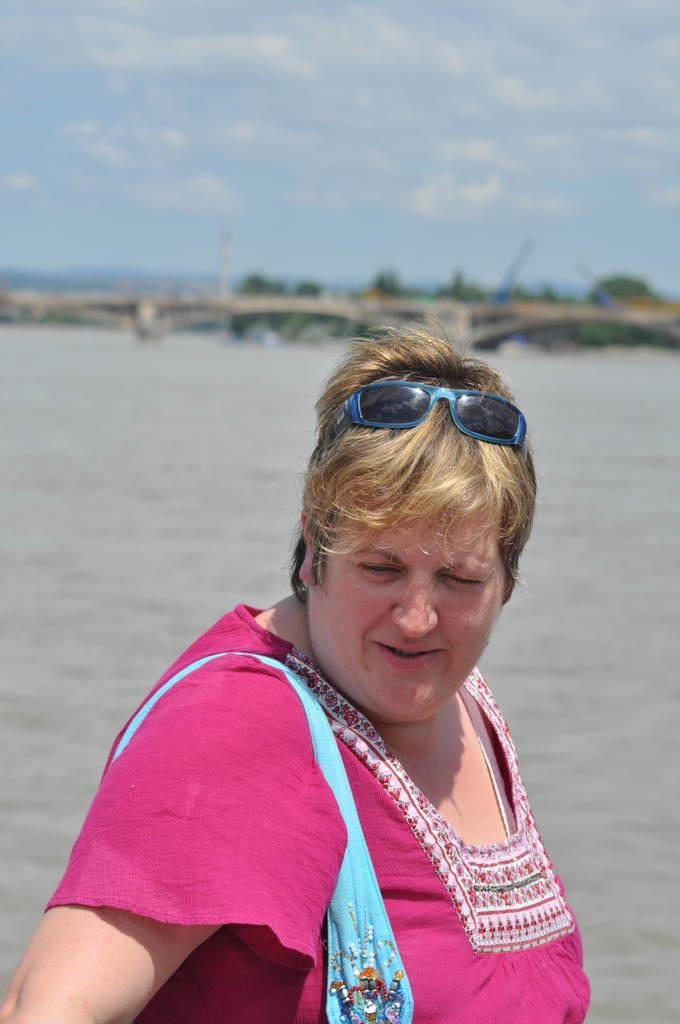What can be seen on the person in the image? The person in the image is wearing spectacles. What is visible in the background of the image? There is water, trees, and the sky visible in the background of the image. Can you see any kites flying in the sky in the image? There is no kite visible in the sky in the image. Is there any quicksand present in the image? There is no quicksand present in the image. 